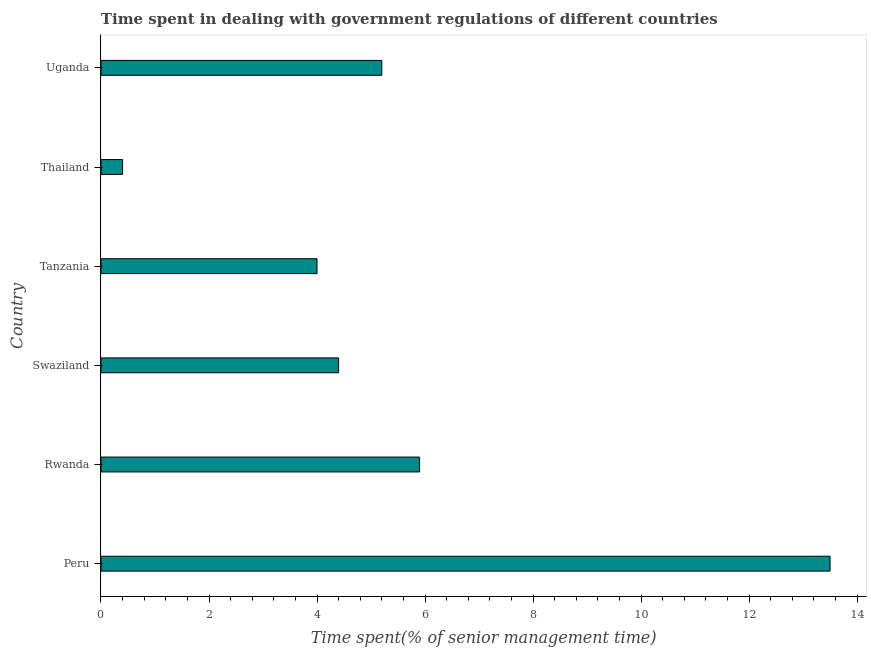Does the graph contain any zero values?
Make the answer very short. No. What is the title of the graph?
Keep it short and to the point. Time spent in dealing with government regulations of different countries. What is the label or title of the X-axis?
Make the answer very short. Time spent(% of senior management time). What is the label or title of the Y-axis?
Your answer should be very brief. Country. What is the time spent in dealing with government regulations in Uganda?
Provide a short and direct response. 5.2. Across all countries, what is the minimum time spent in dealing with government regulations?
Your response must be concise. 0.4. In which country was the time spent in dealing with government regulations minimum?
Give a very brief answer. Thailand. What is the sum of the time spent in dealing with government regulations?
Ensure brevity in your answer.  33.4. What is the average time spent in dealing with government regulations per country?
Your answer should be compact. 5.57. What is the median time spent in dealing with government regulations?
Provide a succinct answer. 4.8. What is the ratio of the time spent in dealing with government regulations in Peru to that in Swaziland?
Keep it short and to the point. 3.07. Is the difference between the time spent in dealing with government regulations in Swaziland and Uganda greater than the difference between any two countries?
Your response must be concise. No. What is the difference between the highest and the second highest time spent in dealing with government regulations?
Ensure brevity in your answer.  7.6. Is the sum of the time spent in dealing with government regulations in Rwanda and Thailand greater than the maximum time spent in dealing with government regulations across all countries?
Make the answer very short. No. What is the difference between the highest and the lowest time spent in dealing with government regulations?
Give a very brief answer. 13.1. How many countries are there in the graph?
Keep it short and to the point. 6. What is the difference between two consecutive major ticks on the X-axis?
Offer a terse response. 2. What is the Time spent(% of senior management time) in Swaziland?
Keep it short and to the point. 4.4. What is the Time spent(% of senior management time) of Tanzania?
Provide a short and direct response. 4. What is the Time spent(% of senior management time) in Thailand?
Offer a terse response. 0.4. What is the difference between the Time spent(% of senior management time) in Peru and Thailand?
Make the answer very short. 13.1. What is the difference between the Time spent(% of senior management time) in Peru and Uganda?
Give a very brief answer. 8.3. What is the difference between the Time spent(% of senior management time) in Rwanda and Swaziland?
Ensure brevity in your answer.  1.5. What is the difference between the Time spent(% of senior management time) in Rwanda and Tanzania?
Your response must be concise. 1.9. What is the difference between the Time spent(% of senior management time) in Swaziland and Uganda?
Make the answer very short. -0.8. What is the difference between the Time spent(% of senior management time) in Tanzania and Thailand?
Your response must be concise. 3.6. What is the difference between the Time spent(% of senior management time) in Tanzania and Uganda?
Provide a succinct answer. -1.2. What is the ratio of the Time spent(% of senior management time) in Peru to that in Rwanda?
Provide a succinct answer. 2.29. What is the ratio of the Time spent(% of senior management time) in Peru to that in Swaziland?
Offer a terse response. 3.07. What is the ratio of the Time spent(% of senior management time) in Peru to that in Tanzania?
Give a very brief answer. 3.38. What is the ratio of the Time spent(% of senior management time) in Peru to that in Thailand?
Your answer should be very brief. 33.75. What is the ratio of the Time spent(% of senior management time) in Peru to that in Uganda?
Give a very brief answer. 2.6. What is the ratio of the Time spent(% of senior management time) in Rwanda to that in Swaziland?
Offer a terse response. 1.34. What is the ratio of the Time spent(% of senior management time) in Rwanda to that in Tanzania?
Offer a terse response. 1.48. What is the ratio of the Time spent(% of senior management time) in Rwanda to that in Thailand?
Offer a terse response. 14.75. What is the ratio of the Time spent(% of senior management time) in Rwanda to that in Uganda?
Give a very brief answer. 1.14. What is the ratio of the Time spent(% of senior management time) in Swaziland to that in Tanzania?
Offer a terse response. 1.1. What is the ratio of the Time spent(% of senior management time) in Swaziland to that in Uganda?
Offer a very short reply. 0.85. What is the ratio of the Time spent(% of senior management time) in Tanzania to that in Uganda?
Ensure brevity in your answer.  0.77. What is the ratio of the Time spent(% of senior management time) in Thailand to that in Uganda?
Offer a very short reply. 0.08. 